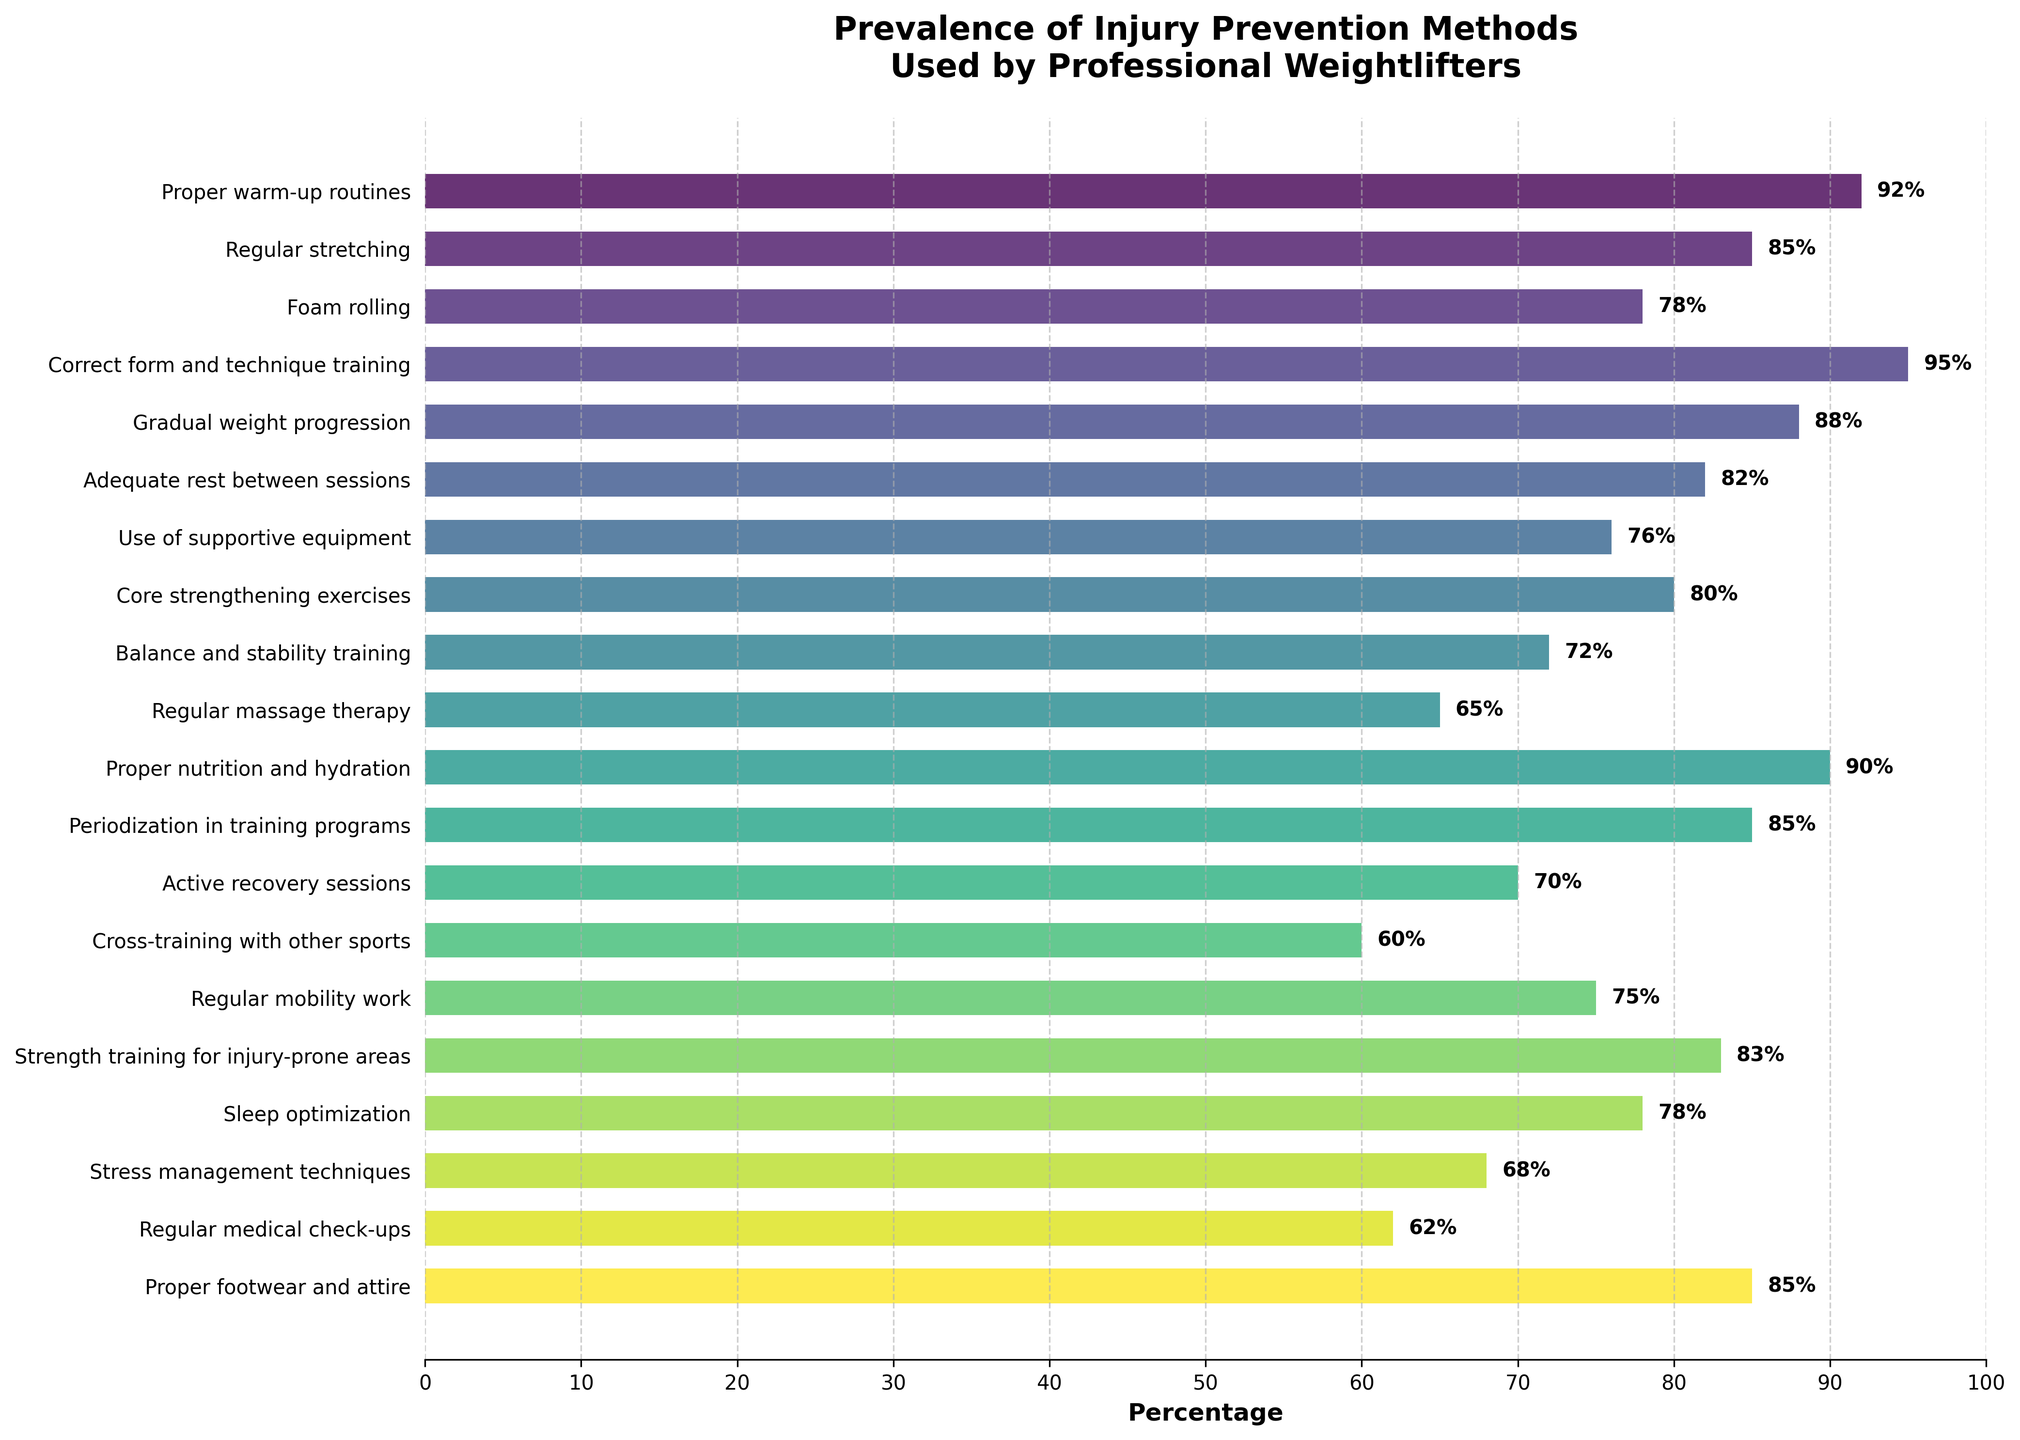Which injury prevention method is used by most weightlifters? The figure shows the methods and their respective percentages. The method with the highest percentage is the one used by most weightlifters. Proper form and technique training is used by 95%.
Answer: Proper form and technique training Which injury prevention method has the lowest prevalence? The figure shows the methods and their respective percentages. The method with the lowest percentage is the one with the least prevalence. Cross-training with other sports is used by 60%.
Answer: Cross-training with other sports What is the total percentage for the three most prevalent methods? The three most prevalent methods are Proper form and technique training (95%), Proper warm-up routines (92%), and Proper nutrition and hydration (90%). The total is calculated as: 95 + 92 + 90 = 277.
Answer: 277 Is the percentage of weightlifters using adequate rest between sessions higher than that of regular stretching? According to the figure, Adequate rest between sessions is used by 82% and Regular stretching by 85%. 82 is less than 85.
Answer: No Which method has a higher percentage, foam rolling or sleep optimization? The figure shows Foam rolling at 78% and Sleep optimization at 78%. Both methods have the same percentage.
Answer: Both methods are equal What is the average percentage of the five least used methods? The five least used methods are Cross-training with other sports (60%), Regular medical check-ups (62%), Regular massage therapy (65%), Stress management techniques (68%), and Active recovery sessions (70%). The sum is 60 + 62 + 65 + 68 + 70 = 325. The average is 325 / 5 = 65.
Answer: 65 Which visual attribute is used to differentiate the bars representing the methods? The figure uses different colors to differentiate the bars representing the methods.
Answer: Different colors What is the difference in percentage between regular mobility work and regular massage therapy? Regular mobility work is used by 75%, and Regular massage therapy is used by 65%. The difference is calculated as 75 - 65 = 10.
Answer: 10 Is the percentage for balance and stability training greater or less than that for core strengthening exercises? The percentage for Balance and stability training is 72%, and for Core strengthening exercises, it is 80%. 72 is less than 80.
Answer: Less Among strength training for injury-prone areas and use of supportive equipment, which one is more prevalent and by how much? Strength training for injury-prone areas is used by 83%, and Use of supportive equipment by 76%. The difference is calculated as 83 - 76 = 7.
Answer: Strength training for injury-prone areas by 7 